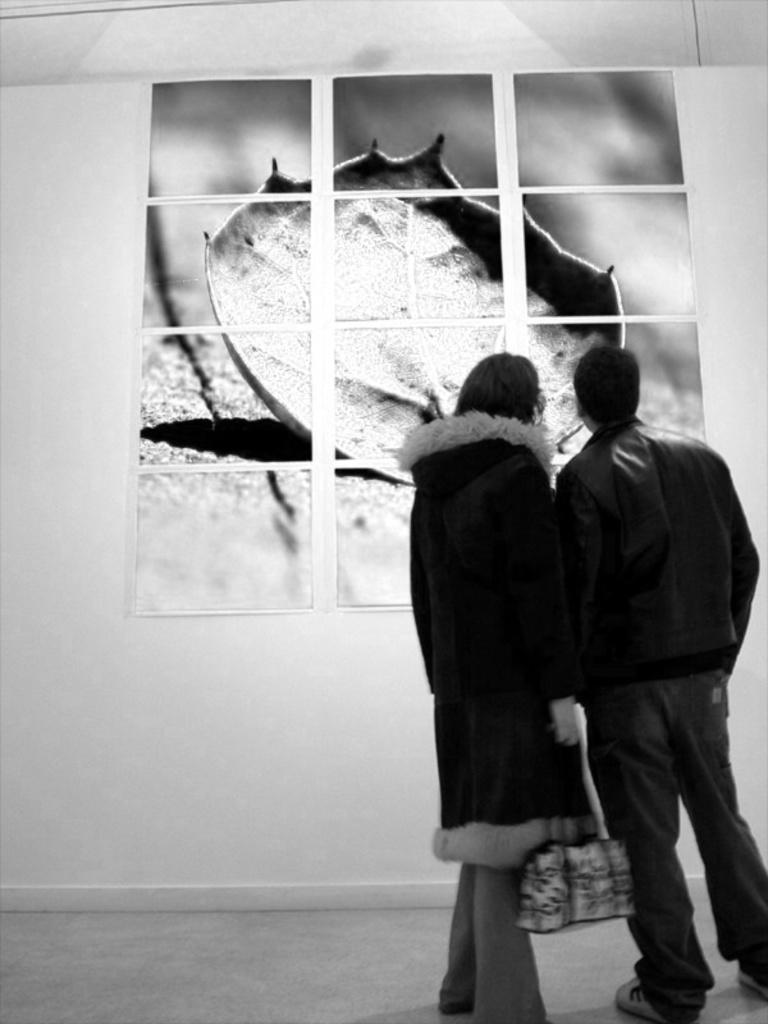What is the color scheme of the image? The image is black and white. How many people are in the image? There are two persons standing on the right side of the image. What is one person holding in the image? One person is holding a bag. What can be seen on the wall in the background of the image? There is a puzzle on the wall in the background of the image. What type of clover is growing on the top of the puzzle in the image? There is no clover present in the image, and the puzzle is on the wall, not on the ground. 